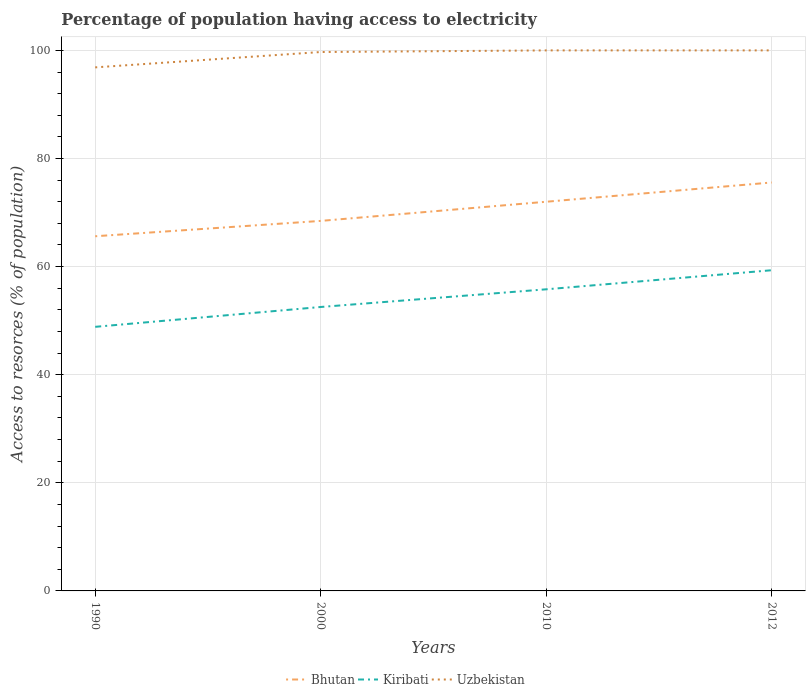How many different coloured lines are there?
Give a very brief answer. 3. Does the line corresponding to Bhutan intersect with the line corresponding to Kiribati?
Give a very brief answer. No. Is the number of lines equal to the number of legend labels?
Your answer should be very brief. Yes. Across all years, what is the maximum percentage of population having access to electricity in Bhutan?
Offer a terse response. 65.62. What is the total percentage of population having access to electricity in Kiribati in the graph?
Keep it short and to the point. -6.8. What is the difference between the highest and the second highest percentage of population having access to electricity in Uzbekistan?
Keep it short and to the point. 3.14. What is the difference between the highest and the lowest percentage of population having access to electricity in Uzbekistan?
Offer a very short reply. 3. Is the percentage of population having access to electricity in Bhutan strictly greater than the percentage of population having access to electricity in Kiribati over the years?
Your answer should be very brief. No. How many years are there in the graph?
Your response must be concise. 4. How many legend labels are there?
Give a very brief answer. 3. How are the legend labels stacked?
Your answer should be very brief. Horizontal. What is the title of the graph?
Provide a succinct answer. Percentage of population having access to electricity. Does "Norway" appear as one of the legend labels in the graph?
Ensure brevity in your answer.  No. What is the label or title of the Y-axis?
Make the answer very short. Access to resorces (% of population). What is the Access to resorces (% of population) in Bhutan in 1990?
Give a very brief answer. 65.62. What is the Access to resorces (% of population) of Kiribati in 1990?
Make the answer very short. 48.86. What is the Access to resorces (% of population) of Uzbekistan in 1990?
Your response must be concise. 96.86. What is the Access to resorces (% of population) of Bhutan in 2000?
Offer a very short reply. 68.46. What is the Access to resorces (% of population) in Kiribati in 2000?
Ensure brevity in your answer.  52.53. What is the Access to resorces (% of population) in Uzbekistan in 2000?
Your answer should be compact. 99.7. What is the Access to resorces (% of population) of Bhutan in 2010?
Ensure brevity in your answer.  72. What is the Access to resorces (% of population) in Kiribati in 2010?
Provide a short and direct response. 55.8. What is the Access to resorces (% of population) in Bhutan in 2012?
Your answer should be compact. 75.56. What is the Access to resorces (% of population) in Kiribati in 2012?
Provide a succinct answer. 59.33. What is the Access to resorces (% of population) of Uzbekistan in 2012?
Offer a terse response. 100. Across all years, what is the maximum Access to resorces (% of population) of Bhutan?
Your answer should be compact. 75.56. Across all years, what is the maximum Access to resorces (% of population) of Kiribati?
Your answer should be compact. 59.33. Across all years, what is the minimum Access to resorces (% of population) of Bhutan?
Your answer should be very brief. 65.62. Across all years, what is the minimum Access to resorces (% of population) in Kiribati?
Provide a succinct answer. 48.86. Across all years, what is the minimum Access to resorces (% of population) in Uzbekistan?
Provide a short and direct response. 96.86. What is the total Access to resorces (% of population) in Bhutan in the graph?
Give a very brief answer. 281.63. What is the total Access to resorces (% of population) of Kiribati in the graph?
Ensure brevity in your answer.  216.52. What is the total Access to resorces (% of population) in Uzbekistan in the graph?
Keep it short and to the point. 396.56. What is the difference between the Access to resorces (% of population) of Bhutan in 1990 and that in 2000?
Your response must be concise. -2.84. What is the difference between the Access to resorces (% of population) of Kiribati in 1990 and that in 2000?
Keep it short and to the point. -3.67. What is the difference between the Access to resorces (% of population) of Uzbekistan in 1990 and that in 2000?
Provide a succinct answer. -2.84. What is the difference between the Access to resorces (% of population) of Bhutan in 1990 and that in 2010?
Your answer should be very brief. -6.38. What is the difference between the Access to resorces (% of population) in Kiribati in 1990 and that in 2010?
Provide a succinct answer. -6.94. What is the difference between the Access to resorces (% of population) of Uzbekistan in 1990 and that in 2010?
Provide a short and direct response. -3.14. What is the difference between the Access to resorces (% of population) in Bhutan in 1990 and that in 2012?
Offer a very short reply. -9.95. What is the difference between the Access to resorces (% of population) of Kiribati in 1990 and that in 2012?
Offer a terse response. -10.47. What is the difference between the Access to resorces (% of population) in Uzbekistan in 1990 and that in 2012?
Keep it short and to the point. -3.14. What is the difference between the Access to resorces (% of population) of Bhutan in 2000 and that in 2010?
Your answer should be very brief. -3.54. What is the difference between the Access to resorces (% of population) in Kiribati in 2000 and that in 2010?
Make the answer very short. -3.27. What is the difference between the Access to resorces (% of population) of Bhutan in 2000 and that in 2012?
Your answer should be very brief. -7.11. What is the difference between the Access to resorces (% of population) in Kiribati in 2000 and that in 2012?
Your answer should be compact. -6.8. What is the difference between the Access to resorces (% of population) in Bhutan in 2010 and that in 2012?
Offer a very short reply. -3.56. What is the difference between the Access to resorces (% of population) of Kiribati in 2010 and that in 2012?
Offer a terse response. -3.53. What is the difference between the Access to resorces (% of population) of Bhutan in 1990 and the Access to resorces (% of population) of Kiribati in 2000?
Give a very brief answer. 13.09. What is the difference between the Access to resorces (% of population) in Bhutan in 1990 and the Access to resorces (% of population) in Uzbekistan in 2000?
Provide a short and direct response. -34.08. What is the difference between the Access to resorces (% of population) in Kiribati in 1990 and the Access to resorces (% of population) in Uzbekistan in 2000?
Make the answer very short. -50.84. What is the difference between the Access to resorces (% of population) of Bhutan in 1990 and the Access to resorces (% of population) of Kiribati in 2010?
Offer a terse response. 9.82. What is the difference between the Access to resorces (% of population) in Bhutan in 1990 and the Access to resorces (% of population) in Uzbekistan in 2010?
Your response must be concise. -34.38. What is the difference between the Access to resorces (% of population) of Kiribati in 1990 and the Access to resorces (% of population) of Uzbekistan in 2010?
Make the answer very short. -51.14. What is the difference between the Access to resorces (% of population) in Bhutan in 1990 and the Access to resorces (% of population) in Kiribati in 2012?
Provide a succinct answer. 6.29. What is the difference between the Access to resorces (% of population) in Bhutan in 1990 and the Access to resorces (% of population) in Uzbekistan in 2012?
Your response must be concise. -34.38. What is the difference between the Access to resorces (% of population) in Kiribati in 1990 and the Access to resorces (% of population) in Uzbekistan in 2012?
Keep it short and to the point. -51.14. What is the difference between the Access to resorces (% of population) in Bhutan in 2000 and the Access to resorces (% of population) in Kiribati in 2010?
Keep it short and to the point. 12.66. What is the difference between the Access to resorces (% of population) in Bhutan in 2000 and the Access to resorces (% of population) in Uzbekistan in 2010?
Ensure brevity in your answer.  -31.54. What is the difference between the Access to resorces (% of population) in Kiribati in 2000 and the Access to resorces (% of population) in Uzbekistan in 2010?
Give a very brief answer. -47.47. What is the difference between the Access to resorces (% of population) in Bhutan in 2000 and the Access to resorces (% of population) in Kiribati in 2012?
Your answer should be compact. 9.13. What is the difference between the Access to resorces (% of population) in Bhutan in 2000 and the Access to resorces (% of population) in Uzbekistan in 2012?
Provide a succinct answer. -31.54. What is the difference between the Access to resorces (% of population) of Kiribati in 2000 and the Access to resorces (% of population) of Uzbekistan in 2012?
Offer a very short reply. -47.47. What is the difference between the Access to resorces (% of population) in Bhutan in 2010 and the Access to resorces (% of population) in Kiribati in 2012?
Keep it short and to the point. 12.67. What is the difference between the Access to resorces (% of population) of Kiribati in 2010 and the Access to resorces (% of population) of Uzbekistan in 2012?
Offer a terse response. -44.2. What is the average Access to resorces (% of population) of Bhutan per year?
Ensure brevity in your answer.  70.41. What is the average Access to resorces (% of population) in Kiribati per year?
Keep it short and to the point. 54.13. What is the average Access to resorces (% of population) of Uzbekistan per year?
Provide a short and direct response. 99.14. In the year 1990, what is the difference between the Access to resorces (% of population) in Bhutan and Access to resorces (% of population) in Kiribati?
Ensure brevity in your answer.  16.76. In the year 1990, what is the difference between the Access to resorces (% of population) of Bhutan and Access to resorces (% of population) of Uzbekistan?
Provide a succinct answer. -31.24. In the year 1990, what is the difference between the Access to resorces (% of population) in Kiribati and Access to resorces (% of population) in Uzbekistan?
Offer a terse response. -48. In the year 2000, what is the difference between the Access to resorces (% of population) in Bhutan and Access to resorces (% of population) in Kiribati?
Your response must be concise. 15.93. In the year 2000, what is the difference between the Access to resorces (% of population) in Bhutan and Access to resorces (% of population) in Uzbekistan?
Ensure brevity in your answer.  -31.24. In the year 2000, what is the difference between the Access to resorces (% of population) in Kiribati and Access to resorces (% of population) in Uzbekistan?
Give a very brief answer. -47.17. In the year 2010, what is the difference between the Access to resorces (% of population) of Bhutan and Access to resorces (% of population) of Kiribati?
Your response must be concise. 16.2. In the year 2010, what is the difference between the Access to resorces (% of population) of Bhutan and Access to resorces (% of population) of Uzbekistan?
Make the answer very short. -28. In the year 2010, what is the difference between the Access to resorces (% of population) in Kiribati and Access to resorces (% of population) in Uzbekistan?
Your answer should be very brief. -44.2. In the year 2012, what is the difference between the Access to resorces (% of population) of Bhutan and Access to resorces (% of population) of Kiribati?
Your response must be concise. 16.23. In the year 2012, what is the difference between the Access to resorces (% of population) in Bhutan and Access to resorces (% of population) in Uzbekistan?
Keep it short and to the point. -24.44. In the year 2012, what is the difference between the Access to resorces (% of population) in Kiribati and Access to resorces (% of population) in Uzbekistan?
Your answer should be very brief. -40.67. What is the ratio of the Access to resorces (% of population) of Bhutan in 1990 to that in 2000?
Offer a very short reply. 0.96. What is the ratio of the Access to resorces (% of population) in Kiribati in 1990 to that in 2000?
Provide a succinct answer. 0.93. What is the ratio of the Access to resorces (% of population) of Uzbekistan in 1990 to that in 2000?
Offer a terse response. 0.97. What is the ratio of the Access to resorces (% of population) in Bhutan in 1990 to that in 2010?
Keep it short and to the point. 0.91. What is the ratio of the Access to resorces (% of population) of Kiribati in 1990 to that in 2010?
Give a very brief answer. 0.88. What is the ratio of the Access to resorces (% of population) of Uzbekistan in 1990 to that in 2010?
Offer a very short reply. 0.97. What is the ratio of the Access to resorces (% of population) of Bhutan in 1990 to that in 2012?
Your response must be concise. 0.87. What is the ratio of the Access to resorces (% of population) in Kiribati in 1990 to that in 2012?
Your answer should be compact. 0.82. What is the ratio of the Access to resorces (% of population) of Uzbekistan in 1990 to that in 2012?
Your answer should be compact. 0.97. What is the ratio of the Access to resorces (% of population) in Bhutan in 2000 to that in 2010?
Ensure brevity in your answer.  0.95. What is the ratio of the Access to resorces (% of population) of Kiribati in 2000 to that in 2010?
Ensure brevity in your answer.  0.94. What is the ratio of the Access to resorces (% of population) of Bhutan in 2000 to that in 2012?
Provide a succinct answer. 0.91. What is the ratio of the Access to resorces (% of population) in Kiribati in 2000 to that in 2012?
Offer a terse response. 0.89. What is the ratio of the Access to resorces (% of population) of Bhutan in 2010 to that in 2012?
Keep it short and to the point. 0.95. What is the ratio of the Access to resorces (% of population) in Kiribati in 2010 to that in 2012?
Offer a very short reply. 0.94. What is the ratio of the Access to resorces (% of population) in Uzbekistan in 2010 to that in 2012?
Your answer should be very brief. 1. What is the difference between the highest and the second highest Access to resorces (% of population) of Bhutan?
Keep it short and to the point. 3.56. What is the difference between the highest and the second highest Access to resorces (% of population) in Kiribati?
Provide a succinct answer. 3.53. What is the difference between the highest and the second highest Access to resorces (% of population) of Uzbekistan?
Your answer should be compact. 0. What is the difference between the highest and the lowest Access to resorces (% of population) of Bhutan?
Give a very brief answer. 9.95. What is the difference between the highest and the lowest Access to resorces (% of population) of Kiribati?
Offer a very short reply. 10.47. What is the difference between the highest and the lowest Access to resorces (% of population) of Uzbekistan?
Make the answer very short. 3.14. 